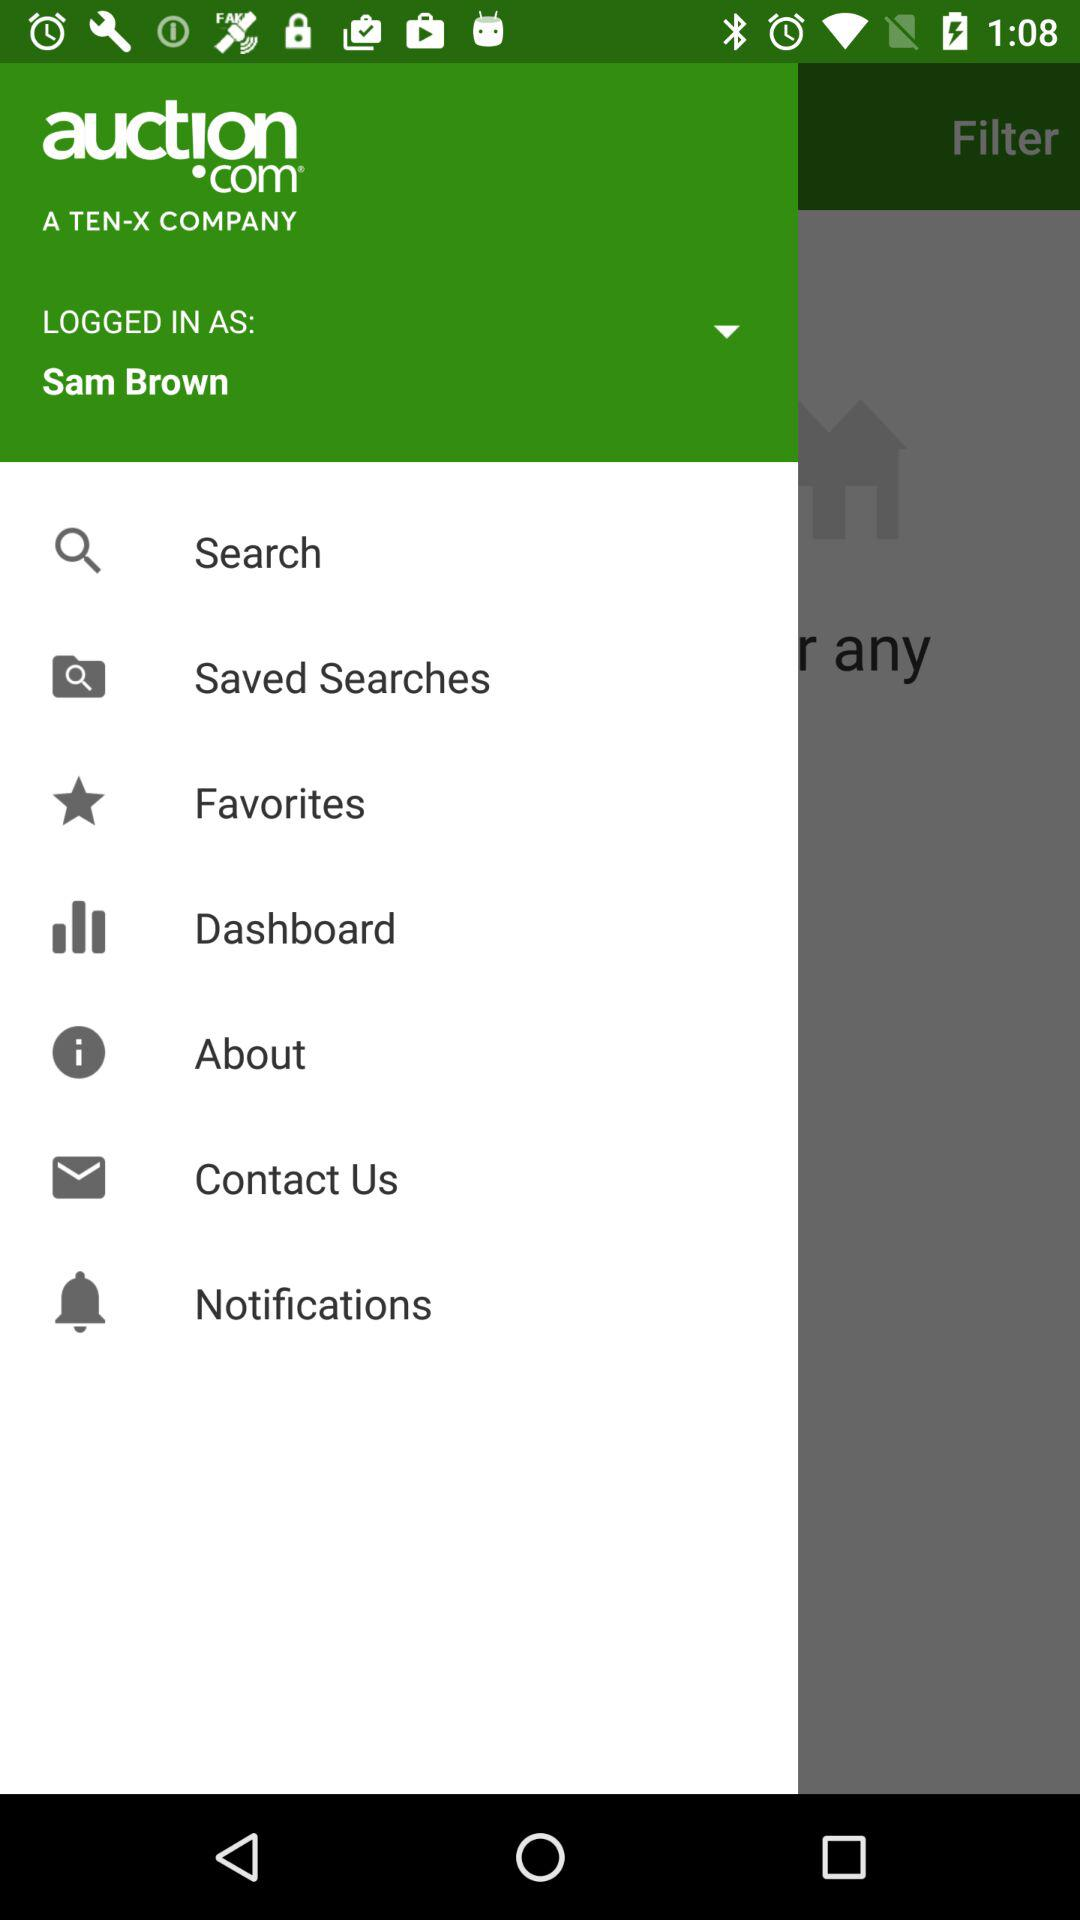What is the profile name? The profile name is Sam Brown. 